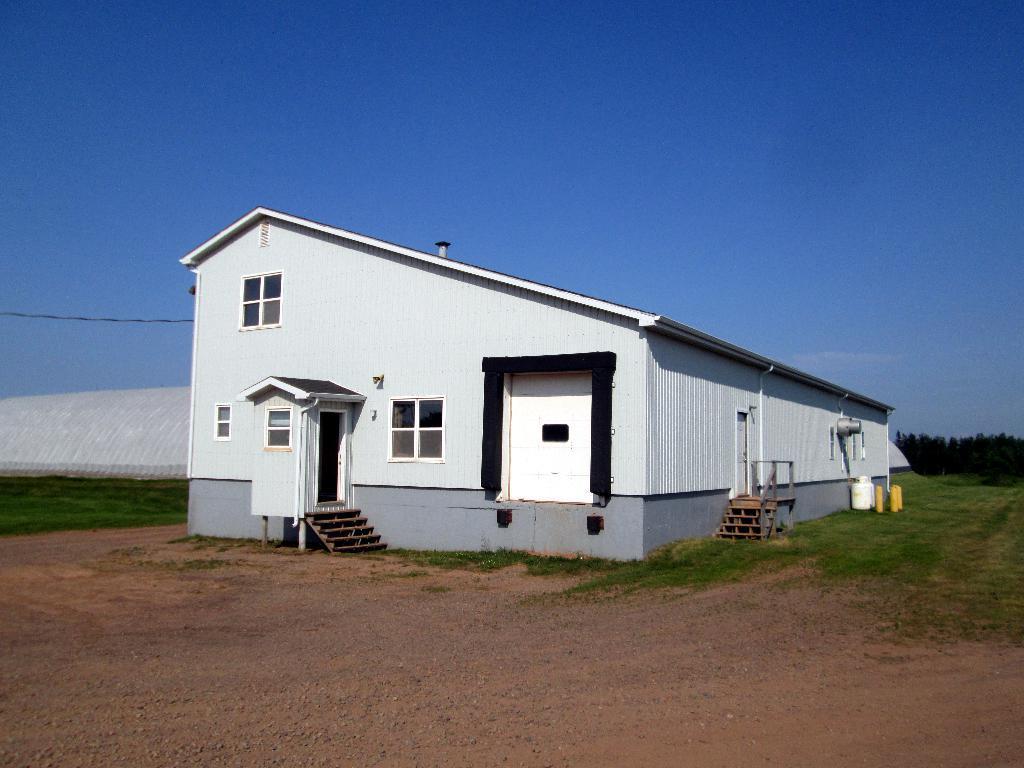How would you summarize this image in a sentence or two? In this picture we can see a house, beside to the house we can find grass and a cable, in the background we can see few trees, and also we can see a shed. 